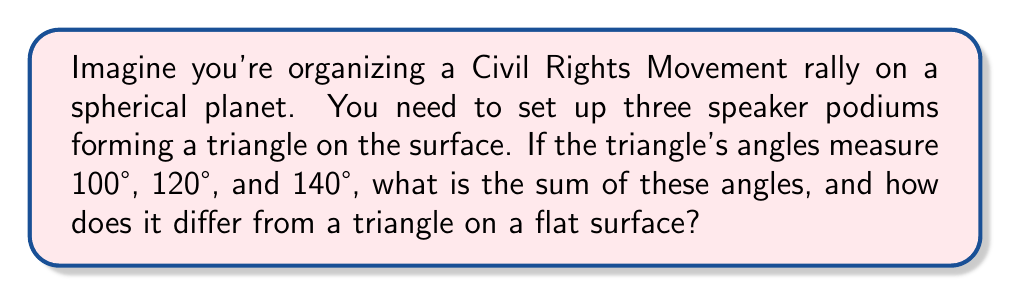What is the answer to this math problem? Let's approach this step-by-step:

1) In Euclidean (flat) geometry, the sum of angles in a triangle is always 180°. However, on a spherical surface, this rule doesn't apply.

2) On a sphere, the sum of angles in a triangle is always greater than 180°. This excess is directly related to the area of the triangle on the sphere's surface.

3) The formula for the sum of angles in a spherical triangle is:

   $$S = \alpha + \beta + \gamma = 180° + \frac{A}{R^2}$$

   Where $S$ is the sum of angles, $\alpha$, $\beta$, and $\gamma$ are the individual angles, $A$ is the area of the triangle, and $R$ is the radius of the sphere.

4) In our case, we don't need to calculate the area. We can simply add the given angles:

   $$S = 100° + 120° + 140° = 360°$$

5) The difference from a flat surface triangle is:

   $$360° - 180° = 180°$$

This excess of 180° is called the spherical excess.

[asy]
import geometry;

size(200);
pair A = (0,0), B = (1,0), C = (0.5, 0.866);
draw(A--B--C--cycle);
label("100°", A, SW);
label("120°", B, SE);
label("140°", C, N);
draw(arc(A, 0.2, 0, 100), Arrow);
draw(arc(B, 0.2, 120, 180), Arrow);
draw(arc(C, 0.2, 220, 320), Arrow);
[/asy]
Answer: 360° 